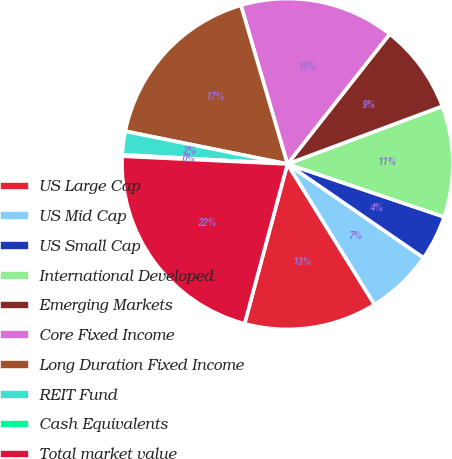Convert chart to OTSL. <chart><loc_0><loc_0><loc_500><loc_500><pie_chart><fcel>US Large Cap<fcel>US Mid Cap<fcel>US Small Cap<fcel>International Developed<fcel>Emerging Markets<fcel>Core Fixed Income<fcel>Long Duration Fixed Income<fcel>REIT Fund<fcel>Cash Equivalents<fcel>Total market value<nl><fcel>13.0%<fcel>6.57%<fcel>4.42%<fcel>10.86%<fcel>8.71%<fcel>15.15%<fcel>17.29%<fcel>2.28%<fcel>0.14%<fcel>21.58%<nl></chart> 